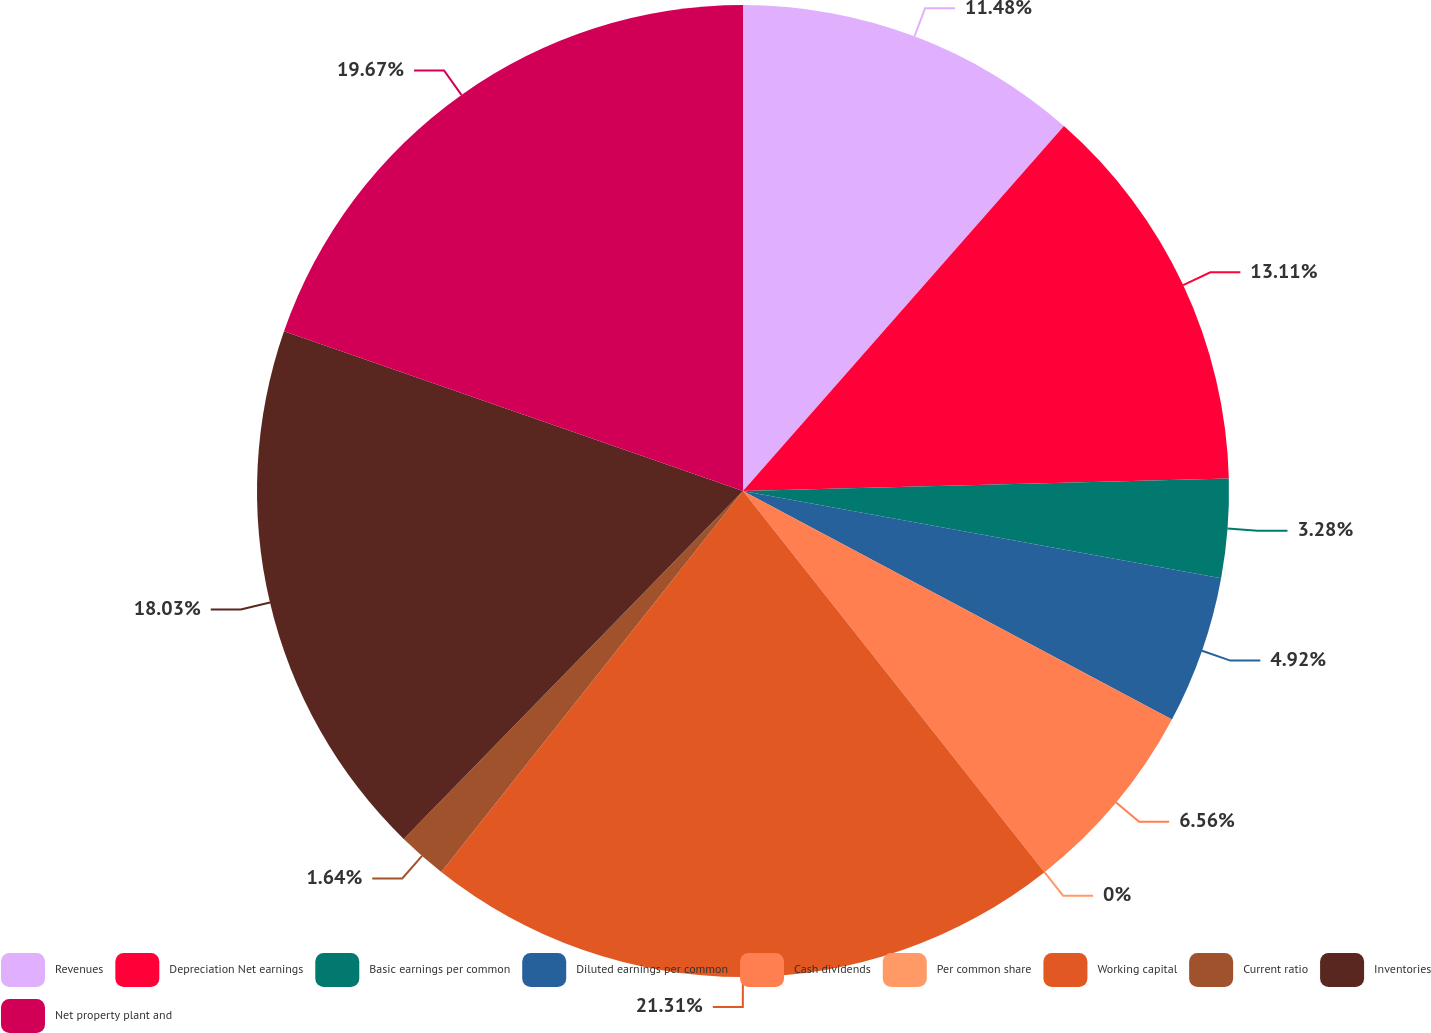<chart> <loc_0><loc_0><loc_500><loc_500><pie_chart><fcel>Revenues<fcel>Depreciation Net earnings<fcel>Basic earnings per common<fcel>Diluted earnings per common<fcel>Cash dividends<fcel>Per common share<fcel>Working capital<fcel>Current ratio<fcel>Inventories<fcel>Net property plant and<nl><fcel>11.48%<fcel>13.11%<fcel>3.28%<fcel>4.92%<fcel>6.56%<fcel>0.0%<fcel>21.31%<fcel>1.64%<fcel>18.03%<fcel>19.67%<nl></chart> 